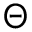Convert formula to latex. <formula><loc_0><loc_0><loc_500><loc_500>\Theta</formula> 